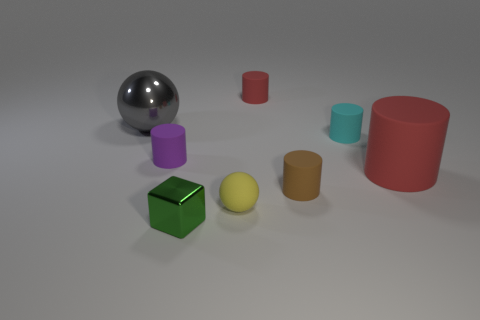How many cyan metal cubes have the same size as the green thing?
Offer a terse response. 0. What is the shape of the red object behind the shiny thing behind the tiny cube?
Offer a very short reply. Cylinder. Is the number of red metallic spheres less than the number of small shiny blocks?
Give a very brief answer. Yes. There is a cylinder left of the small yellow matte sphere; what color is it?
Provide a short and direct response. Purple. The small thing that is both behind the big red cylinder and to the left of the tiny red thing is made of what material?
Keep it short and to the point. Rubber. What shape is the tiny thing that is the same material as the big sphere?
Provide a succinct answer. Cube. There is a metal object right of the big metal sphere; what number of big metal objects are in front of it?
Provide a succinct answer. 0. What number of metal objects are in front of the brown cylinder and behind the brown cylinder?
Offer a very short reply. 0. How many other things are there of the same material as the tiny brown object?
Offer a terse response. 5. What color is the big metallic thing that is on the left side of the large thing in front of the purple matte cylinder?
Make the answer very short. Gray. 